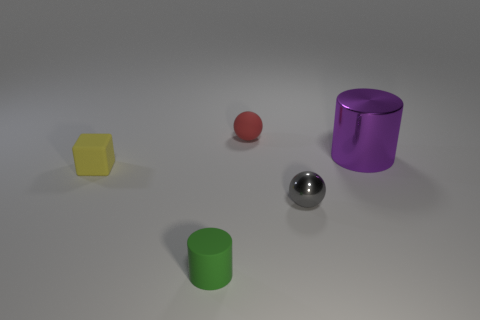How big is the cylinder that is behind the cylinder that is in front of the tiny shiny thing in front of the red matte ball?
Your answer should be compact. Large. What size is the green cylinder that is the same material as the red thing?
Ensure brevity in your answer.  Small. There is a green rubber cylinder; is it the same size as the rubber thing that is on the left side of the tiny green cylinder?
Your response must be concise. Yes. What is the shape of the small object right of the tiny red matte sphere?
Provide a succinct answer. Sphere. Are there any small rubber things that are left of the cylinder in front of the shiny object behind the small gray sphere?
Your answer should be very brief. Yes. What material is the other red object that is the same shape as the tiny shiny object?
Ensure brevity in your answer.  Rubber. How many cubes are purple objects or tiny gray shiny objects?
Your response must be concise. 0. Do the ball that is to the right of the tiny red rubber object and the cylinder in front of the purple metallic cylinder have the same size?
Offer a terse response. Yes. What material is the cylinder in front of the thing on the left side of the tiny cylinder?
Your answer should be very brief. Rubber. Is the number of green matte things right of the gray metal object less than the number of big cylinders?
Your answer should be compact. Yes. 